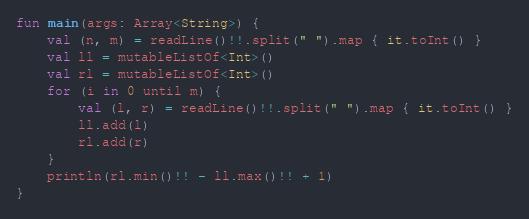Convert code to text. <code><loc_0><loc_0><loc_500><loc_500><_Kotlin_>fun main(args: Array<String>) {
    val (n, m) = readLine()!!.split(" ").map { it.toInt() }
    val ll = mutableListOf<Int>()
    val rl = mutableListOf<Int>()
    for (i in 0 until m) {
        val (l, r) = readLine()!!.split(" ").map { it.toInt() }
        ll.add(l)
        rl.add(r)
    }
    println(rl.min()!! - ll.max()!! + 1)
}
</code> 